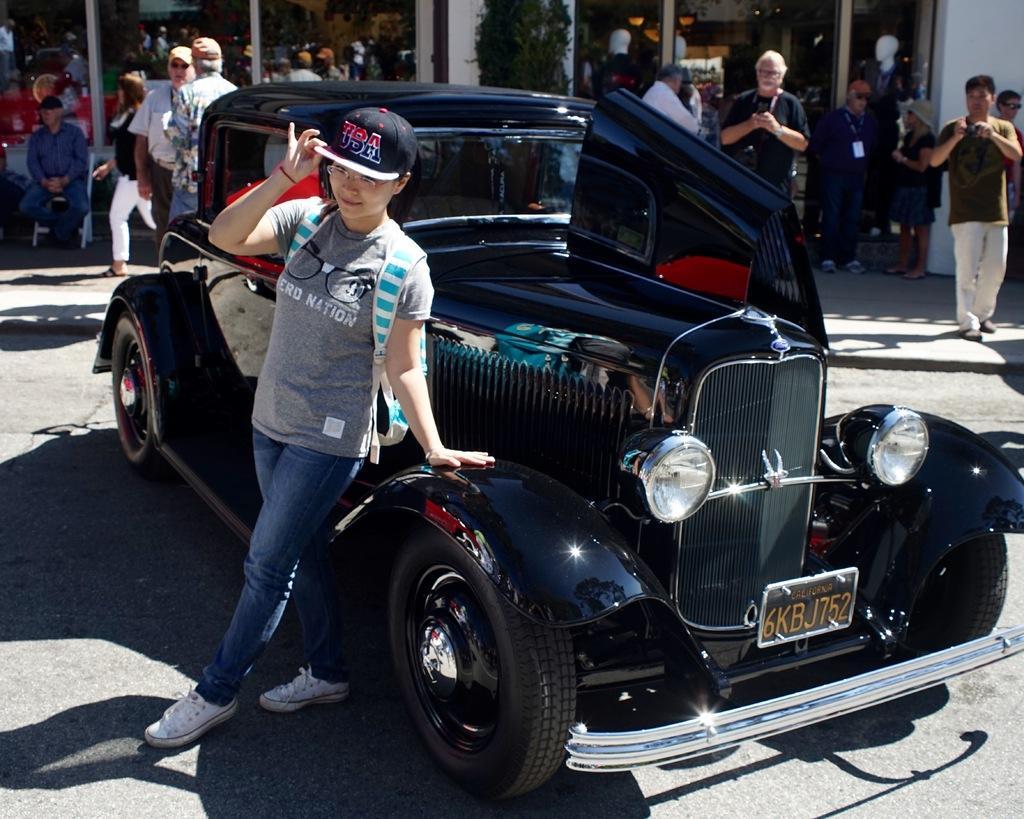Can you describe this image briefly? In the image in the center we can see one vehicle on the road and we can see one person standing. In the background there is a wall,glass,banners,chair,mannequins,few people were standing and few other objects. 